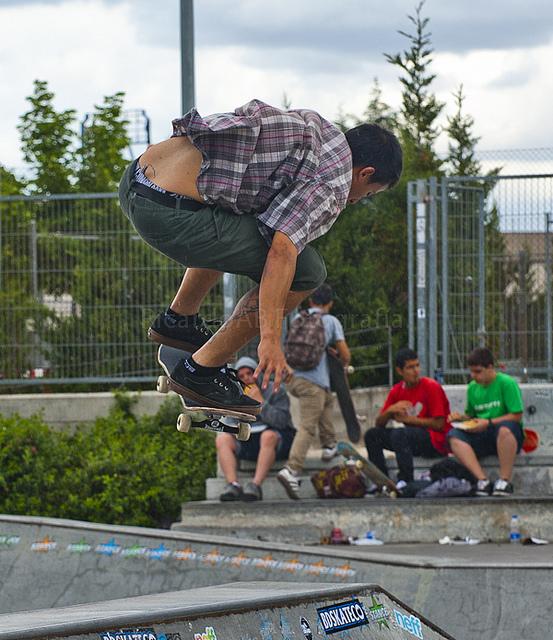Is this taken in the daytime?
Short answer required. Yes. Are the man's feet touching the skateboard?
Keep it brief. Yes. Why are the sitting boys ignoring the man?
Be succinct. They are talking. 